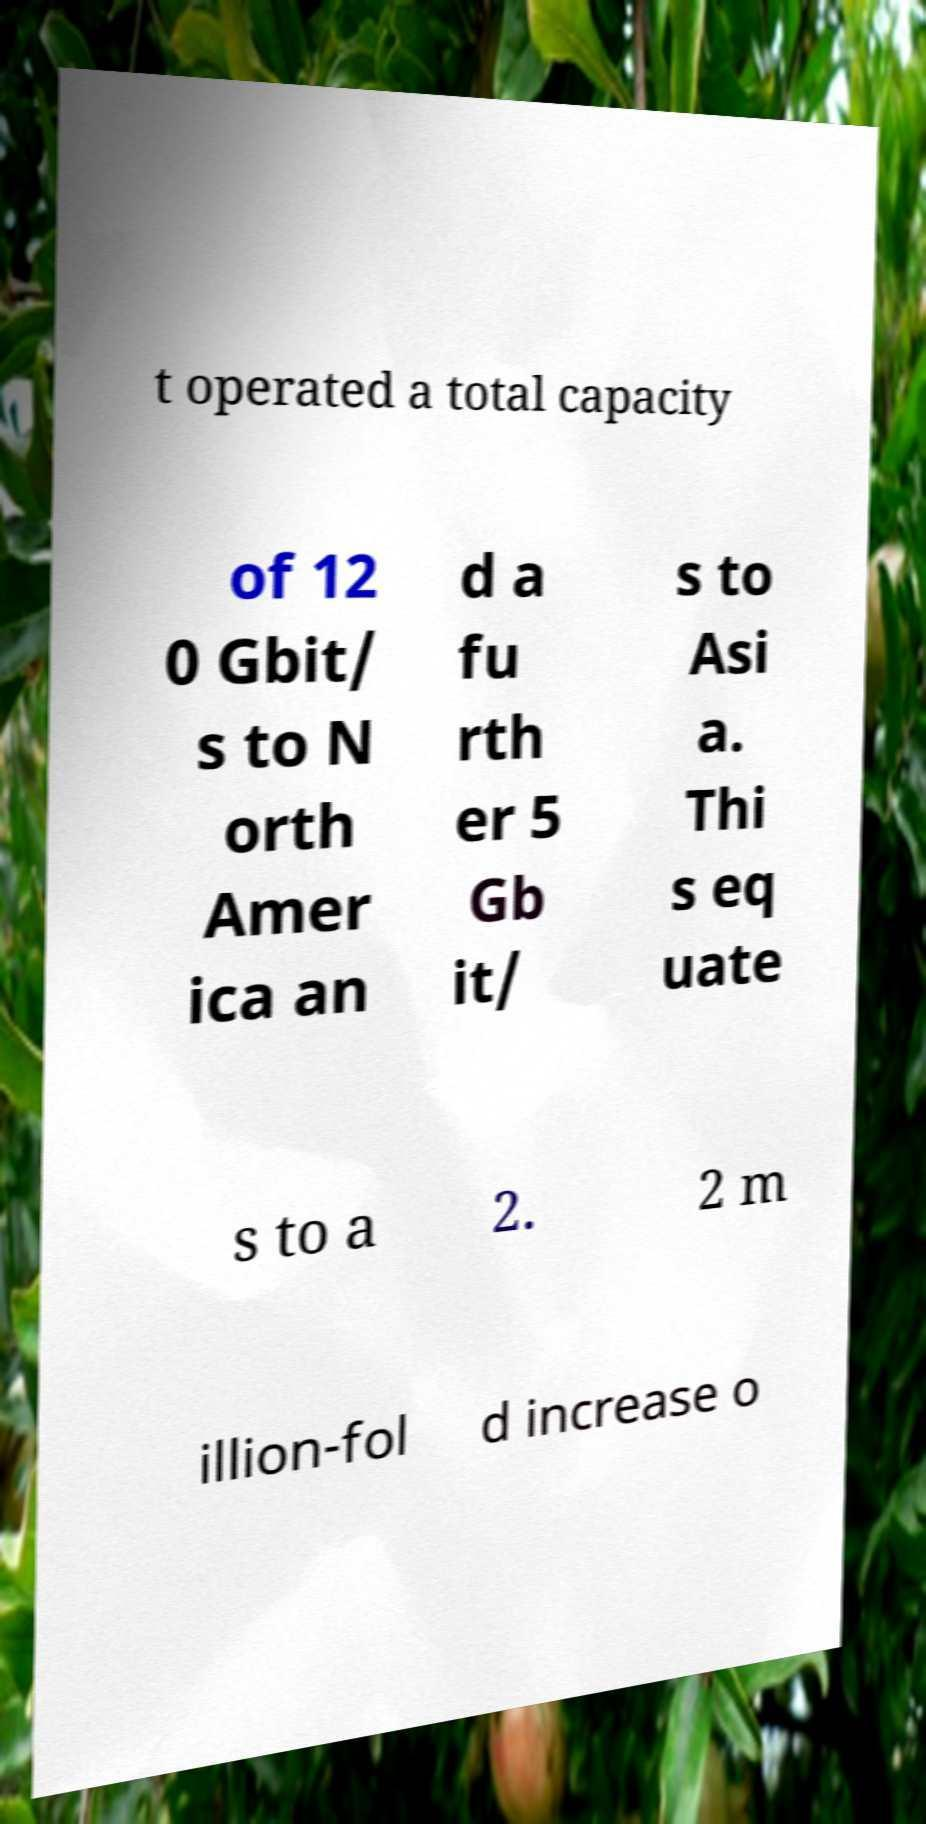Please read and relay the text visible in this image. What does it say? t operated a total capacity of 12 0 Gbit/ s to N orth Amer ica an d a fu rth er 5 Gb it/ s to Asi a. Thi s eq uate s to a 2. 2 m illion-fol d increase o 